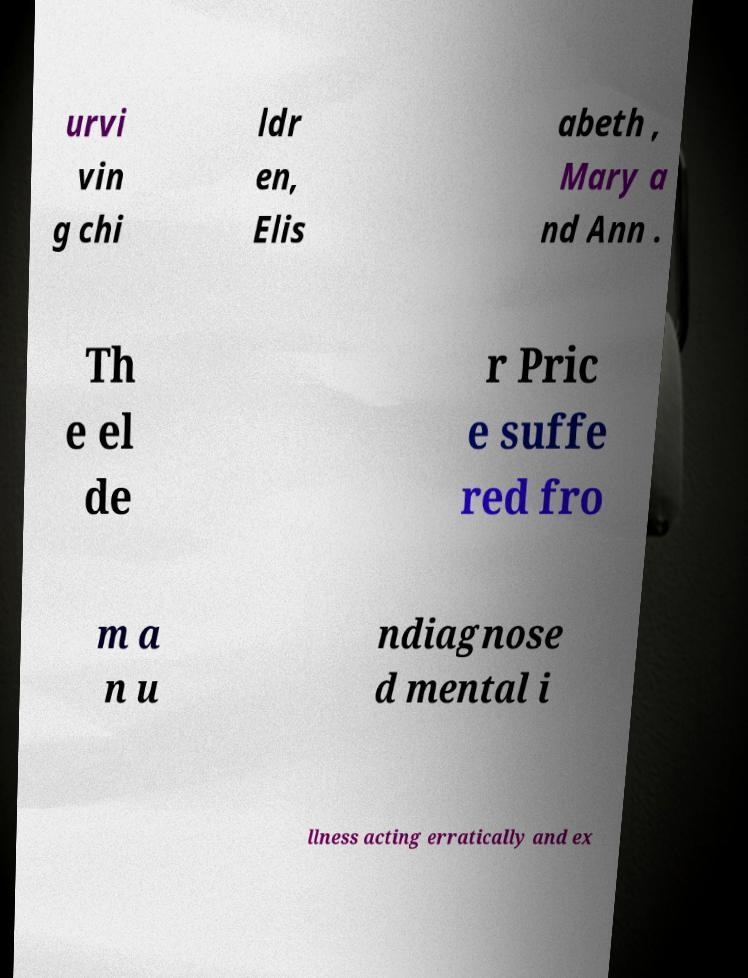Could you extract and type out the text from this image? urvi vin g chi ldr en, Elis abeth , Mary a nd Ann . Th e el de r Pric e suffe red fro m a n u ndiagnose d mental i llness acting erratically and ex 